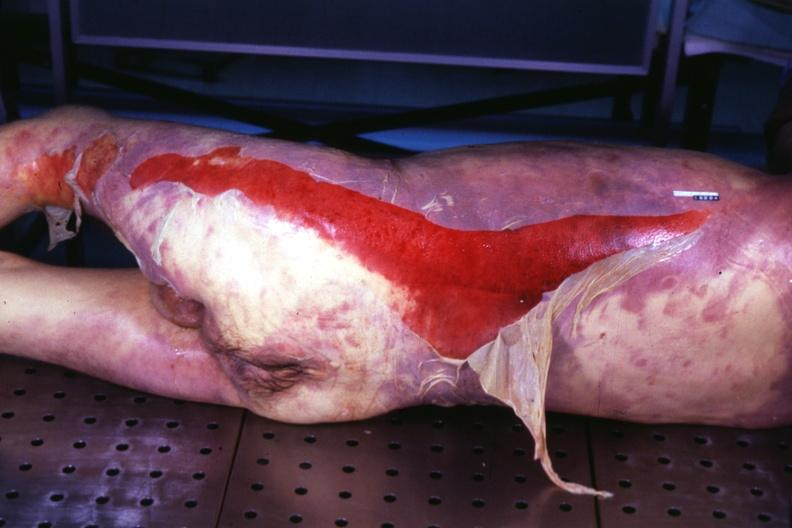what is present?
Answer the question using a single word or phrase. Palpable purpura with desquamation 